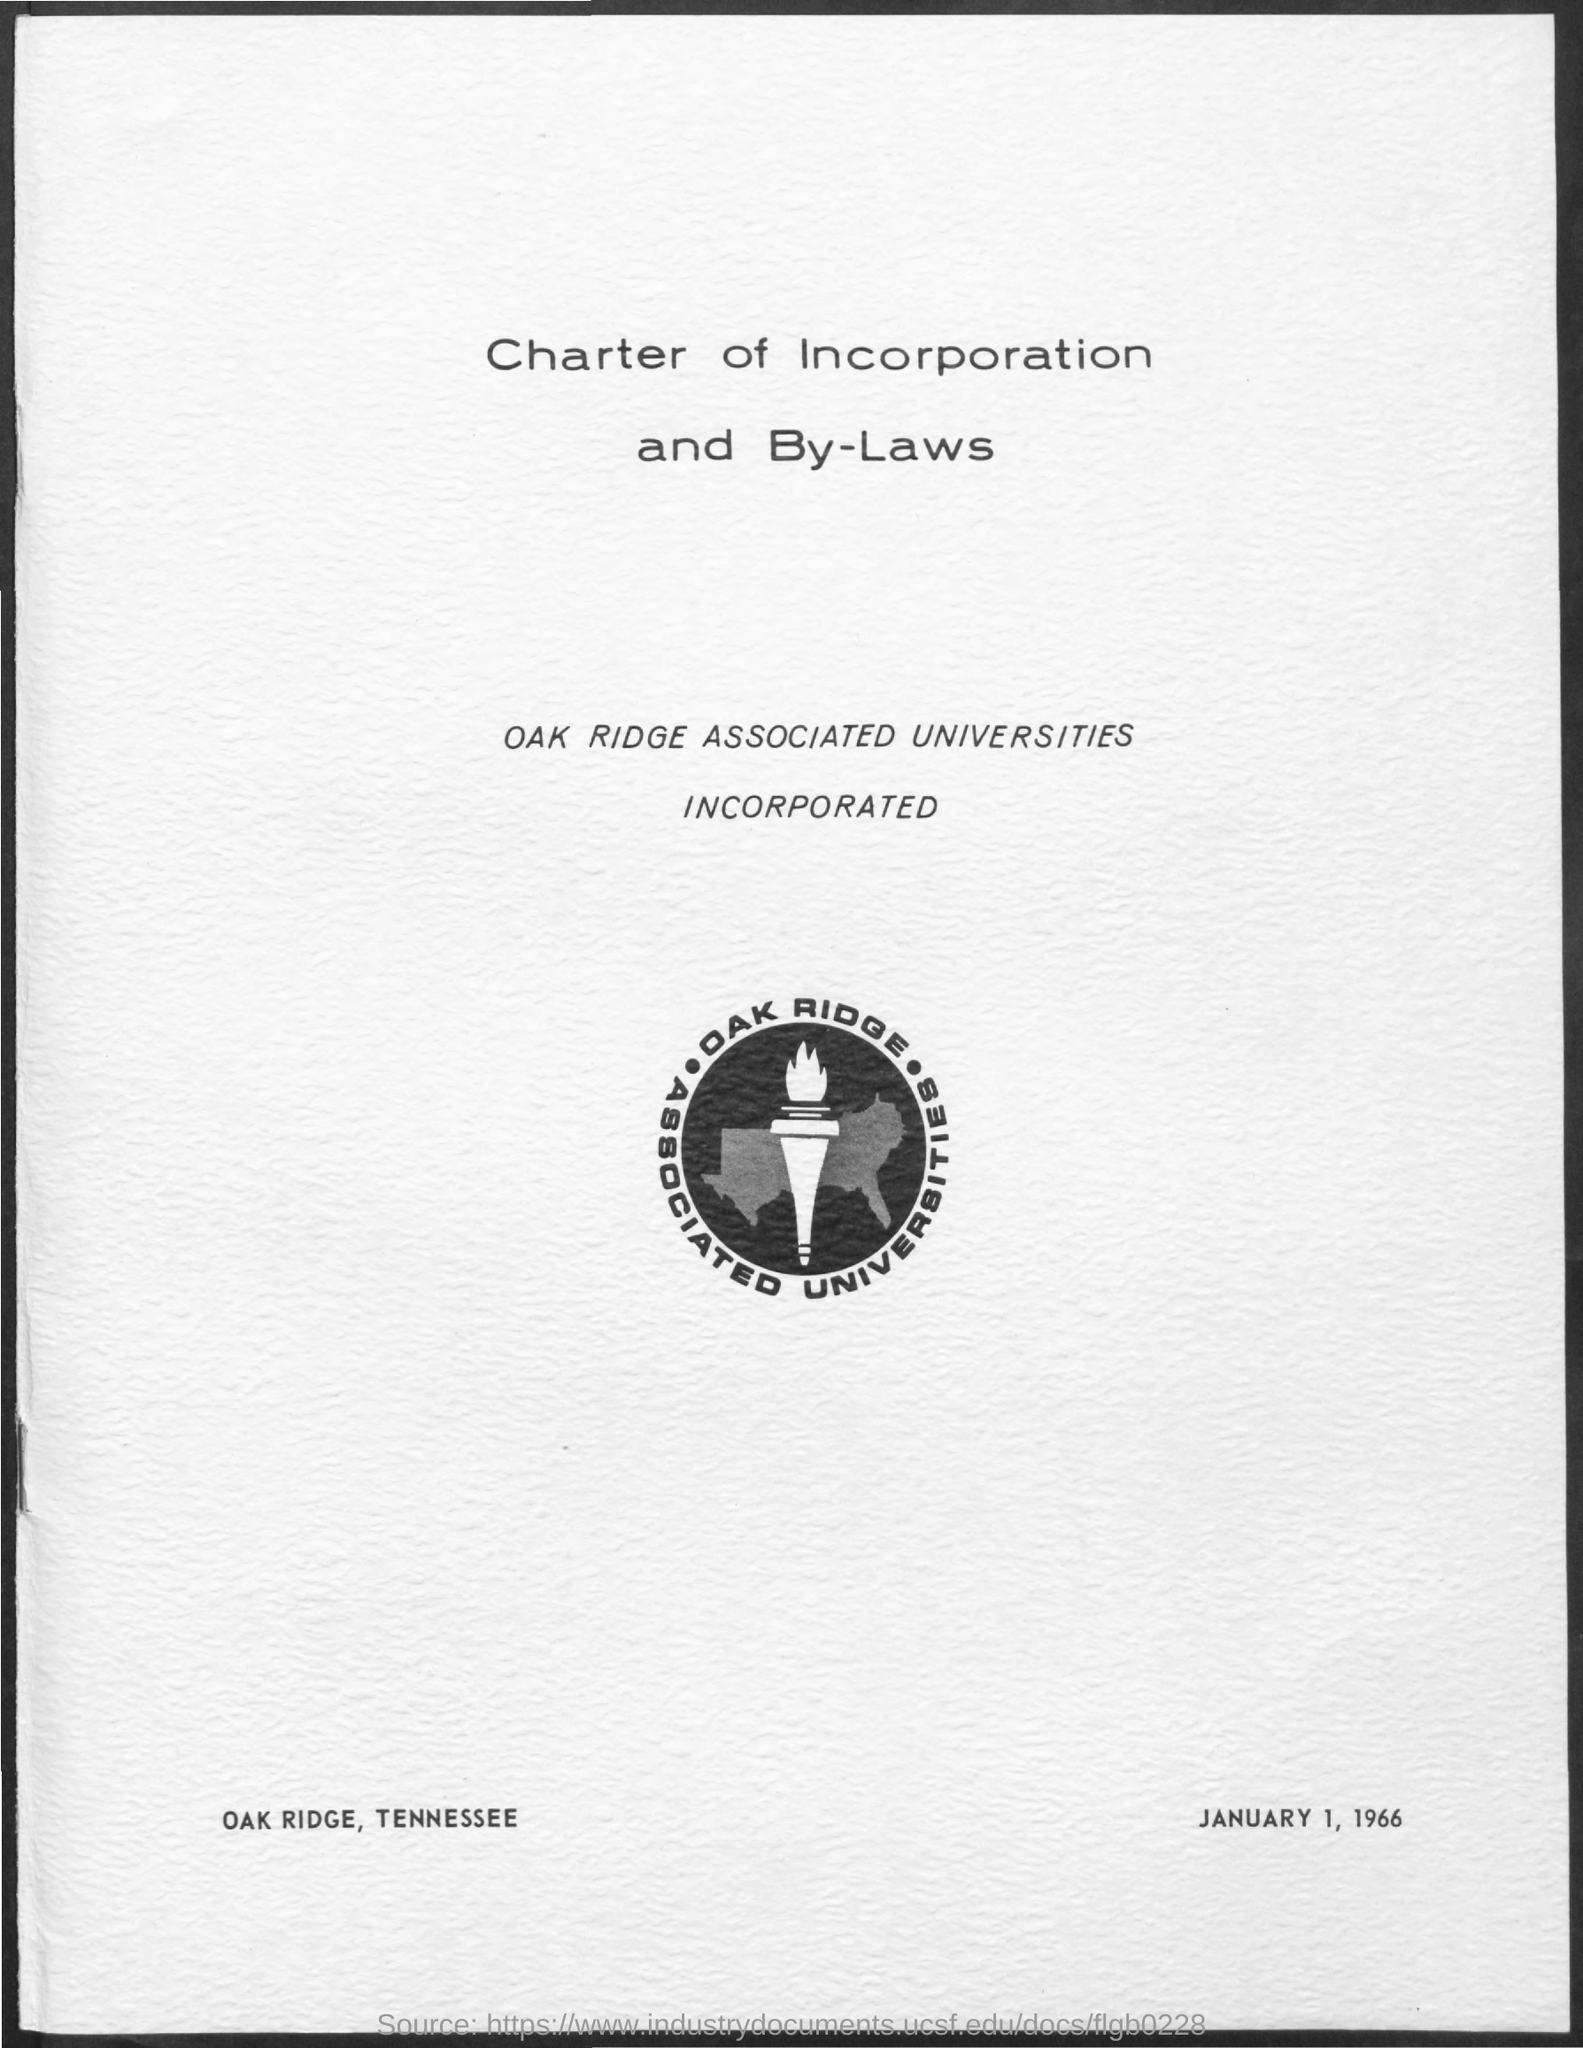What is the date mentioned in the document?
Offer a terse response. January 1,1966. What is the title of the document?
Give a very brief answer. Charter of Incorporation and By-Laws. Oak Ridge is in which U.S State?
Offer a terse response. Tennessee. 